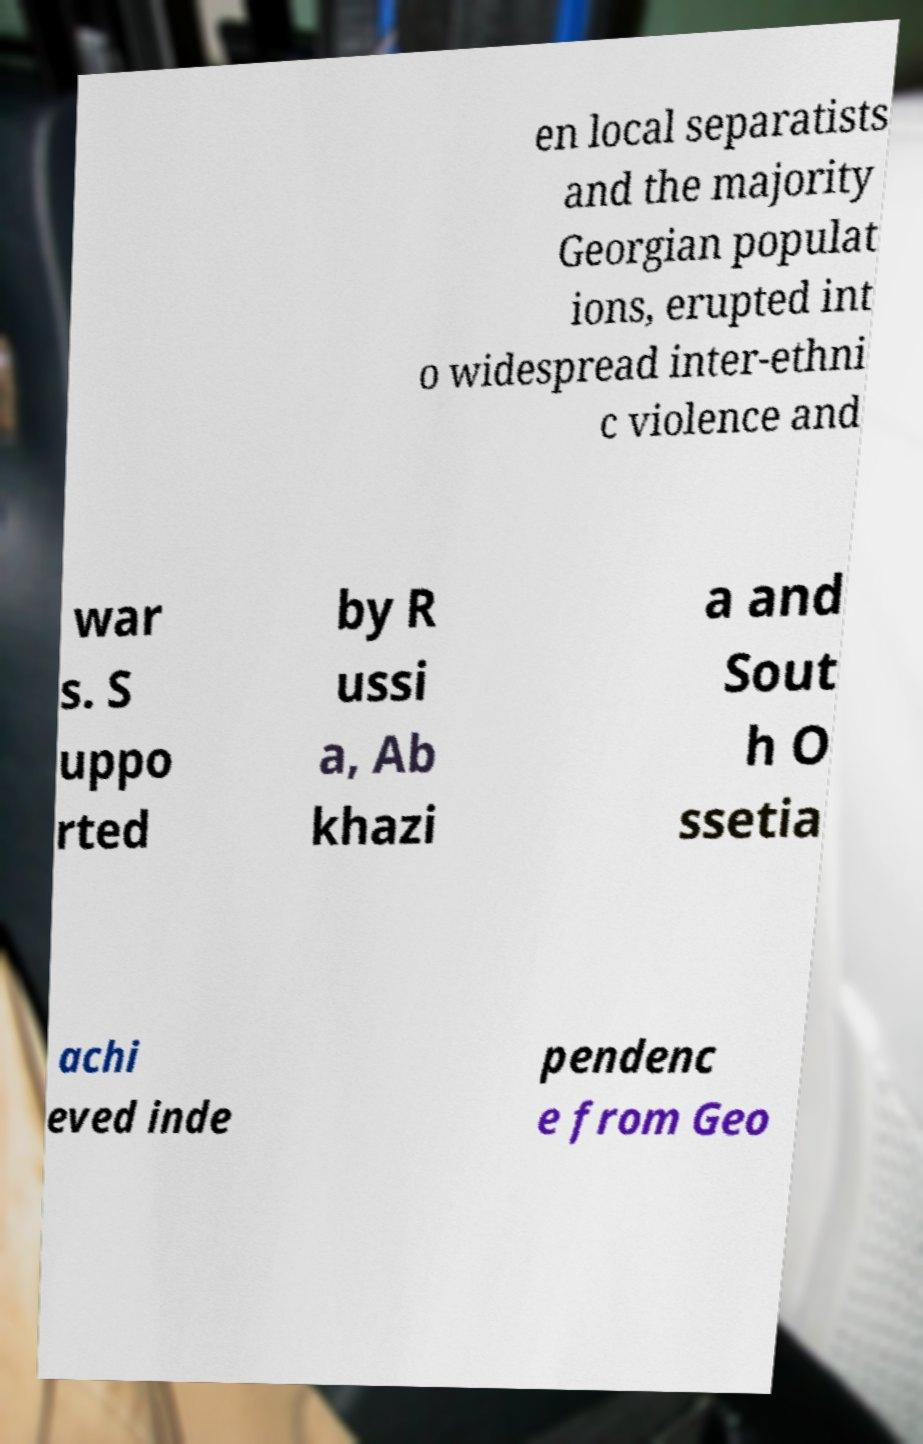There's text embedded in this image that I need extracted. Can you transcribe it verbatim? en local separatists and the majority Georgian populat ions, erupted int o widespread inter-ethni c violence and war s. S uppo rted by R ussi a, Ab khazi a and Sout h O ssetia achi eved inde pendenc e from Geo 